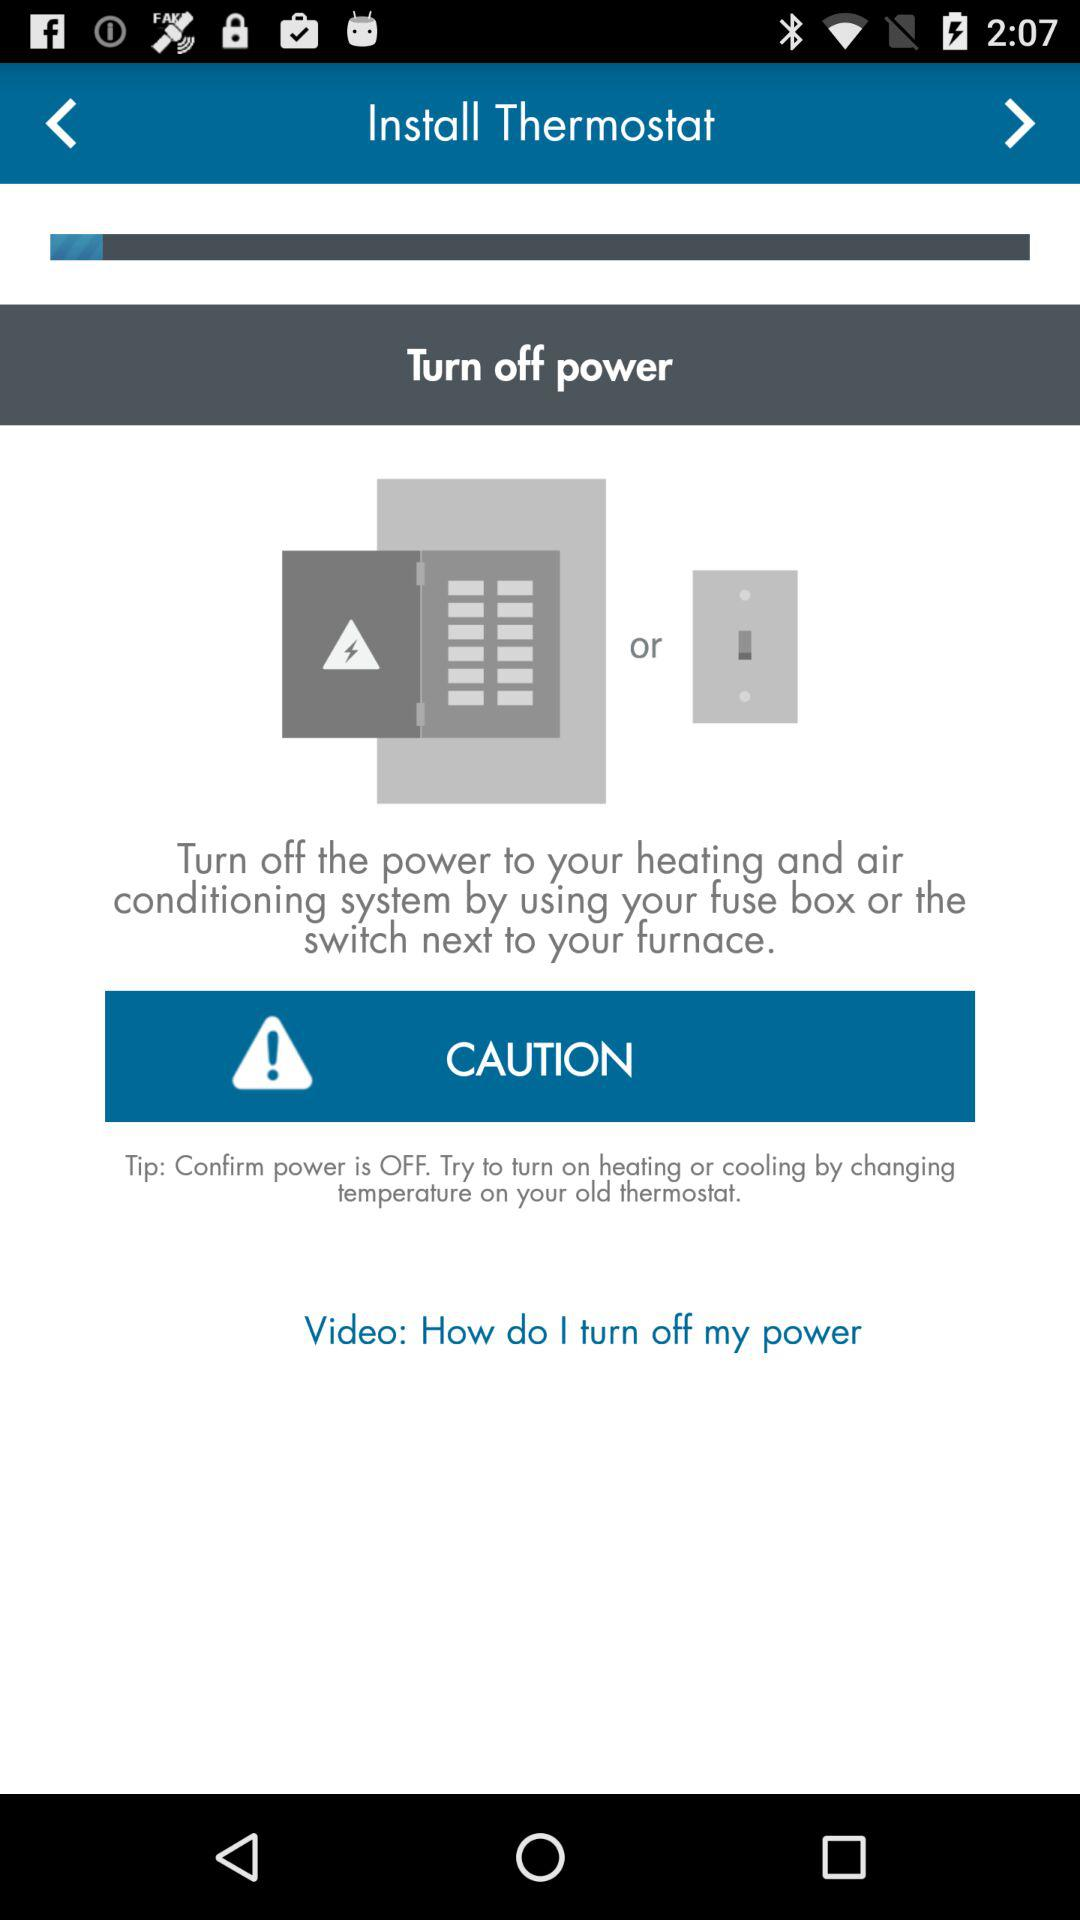How many different ways can you turn off power?
Answer the question using a single word or phrase. 2 